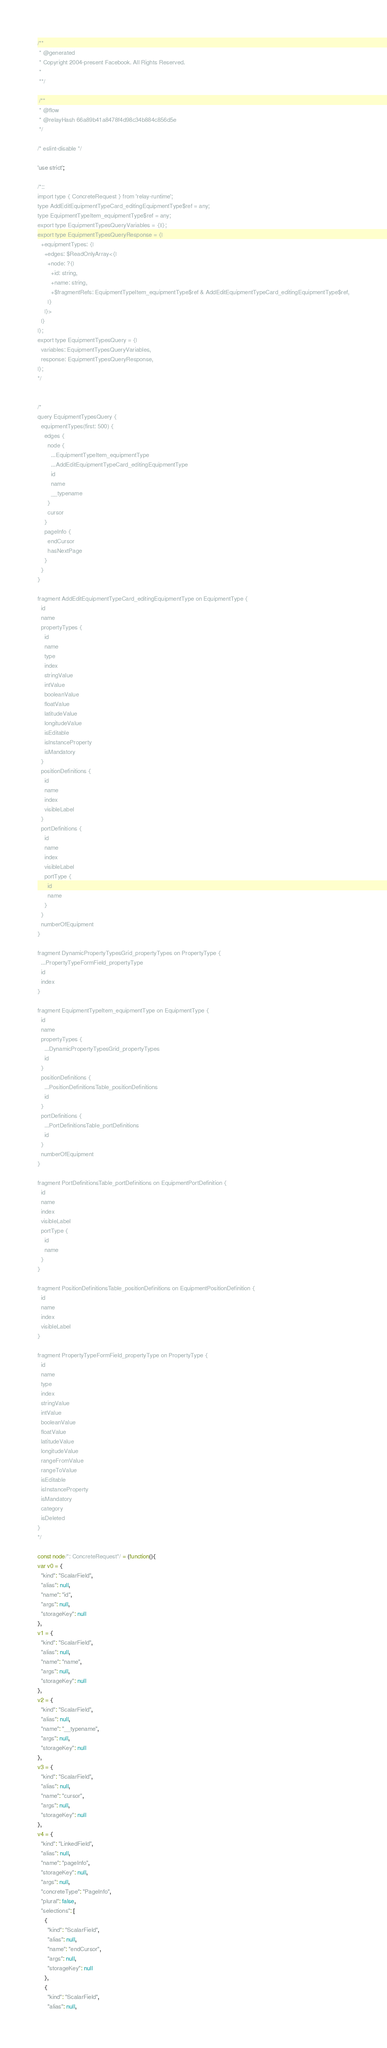Convert code to text. <code><loc_0><loc_0><loc_500><loc_500><_JavaScript_>/**
 * @generated
 * Copyright 2004-present Facebook. All Rights Reserved.
 *
 **/

 /**
 * @flow
 * @relayHash 66a89b41a8478f4d98c34b884c856d5e
 */

/* eslint-disable */

'use strict';

/*::
import type { ConcreteRequest } from 'relay-runtime';
type AddEditEquipmentTypeCard_editingEquipmentType$ref = any;
type EquipmentTypeItem_equipmentType$ref = any;
export type EquipmentTypesQueryVariables = {||};
export type EquipmentTypesQueryResponse = {|
  +equipmentTypes: {|
    +edges: $ReadOnlyArray<{|
      +node: ?{|
        +id: string,
        +name: string,
        +$fragmentRefs: EquipmentTypeItem_equipmentType$ref & AddEditEquipmentTypeCard_editingEquipmentType$ref,
      |}
    |}>
  |}
|};
export type EquipmentTypesQuery = {|
  variables: EquipmentTypesQueryVariables,
  response: EquipmentTypesQueryResponse,
|};
*/


/*
query EquipmentTypesQuery {
  equipmentTypes(first: 500) {
    edges {
      node {
        ...EquipmentTypeItem_equipmentType
        ...AddEditEquipmentTypeCard_editingEquipmentType
        id
        name
        __typename
      }
      cursor
    }
    pageInfo {
      endCursor
      hasNextPage
    }
  }
}

fragment AddEditEquipmentTypeCard_editingEquipmentType on EquipmentType {
  id
  name
  propertyTypes {
    id
    name
    type
    index
    stringValue
    intValue
    booleanValue
    floatValue
    latitudeValue
    longitudeValue
    isEditable
    isInstanceProperty
    isMandatory
  }
  positionDefinitions {
    id
    name
    index
    visibleLabel
  }
  portDefinitions {
    id
    name
    index
    visibleLabel
    portType {
      id
      name
    }
  }
  numberOfEquipment
}

fragment DynamicPropertyTypesGrid_propertyTypes on PropertyType {
  ...PropertyTypeFormField_propertyType
  id
  index
}

fragment EquipmentTypeItem_equipmentType on EquipmentType {
  id
  name
  propertyTypes {
    ...DynamicPropertyTypesGrid_propertyTypes
    id
  }
  positionDefinitions {
    ...PositionDefinitionsTable_positionDefinitions
    id
  }
  portDefinitions {
    ...PortDefinitionsTable_portDefinitions
    id
  }
  numberOfEquipment
}

fragment PortDefinitionsTable_portDefinitions on EquipmentPortDefinition {
  id
  name
  index
  visibleLabel
  portType {
    id
    name
  }
}

fragment PositionDefinitionsTable_positionDefinitions on EquipmentPositionDefinition {
  id
  name
  index
  visibleLabel
}

fragment PropertyTypeFormField_propertyType on PropertyType {
  id
  name
  type
  index
  stringValue
  intValue
  booleanValue
  floatValue
  latitudeValue
  longitudeValue
  rangeFromValue
  rangeToValue
  isEditable
  isInstanceProperty
  isMandatory
  category
  isDeleted
}
*/

const node/*: ConcreteRequest*/ = (function(){
var v0 = {
  "kind": "ScalarField",
  "alias": null,
  "name": "id",
  "args": null,
  "storageKey": null
},
v1 = {
  "kind": "ScalarField",
  "alias": null,
  "name": "name",
  "args": null,
  "storageKey": null
},
v2 = {
  "kind": "ScalarField",
  "alias": null,
  "name": "__typename",
  "args": null,
  "storageKey": null
},
v3 = {
  "kind": "ScalarField",
  "alias": null,
  "name": "cursor",
  "args": null,
  "storageKey": null
},
v4 = {
  "kind": "LinkedField",
  "alias": null,
  "name": "pageInfo",
  "storageKey": null,
  "args": null,
  "concreteType": "PageInfo",
  "plural": false,
  "selections": [
    {
      "kind": "ScalarField",
      "alias": null,
      "name": "endCursor",
      "args": null,
      "storageKey": null
    },
    {
      "kind": "ScalarField",
      "alias": null,</code> 